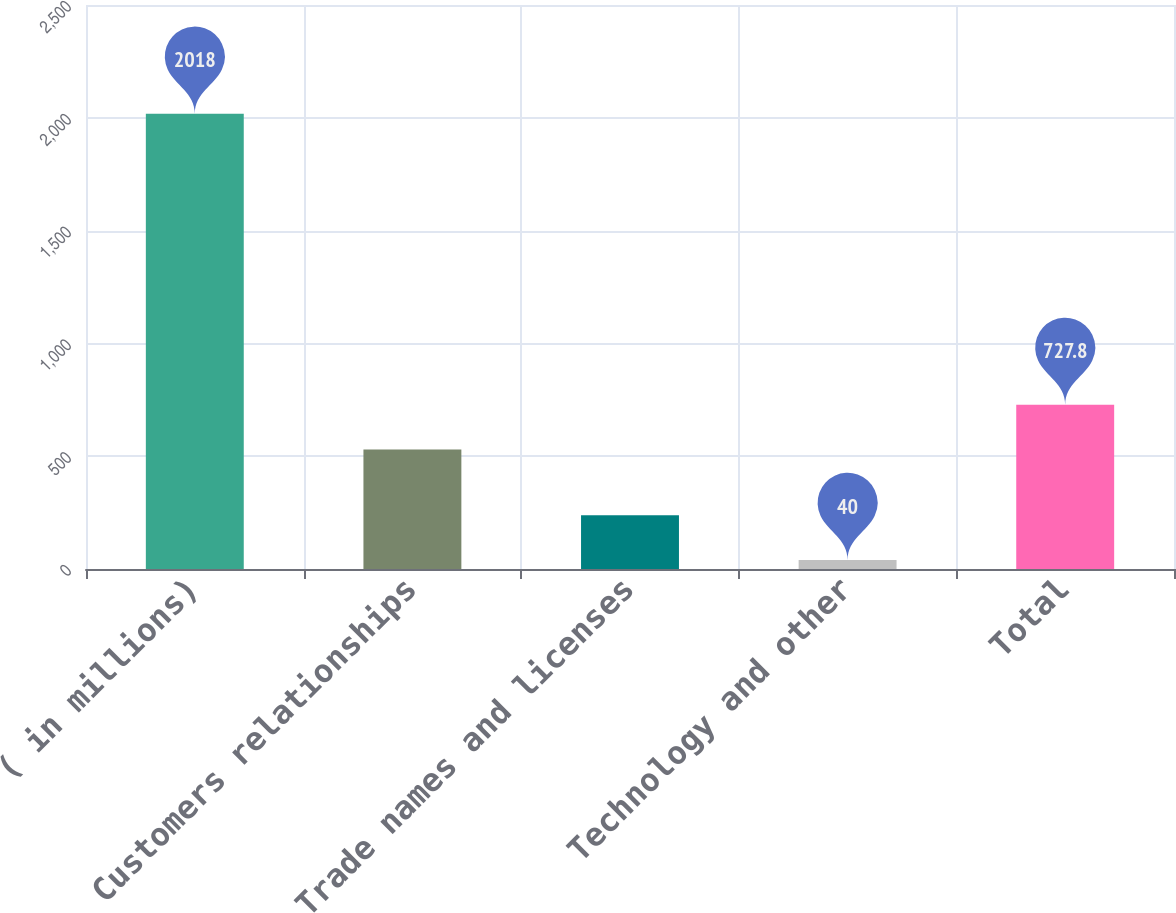<chart> <loc_0><loc_0><loc_500><loc_500><bar_chart><fcel>( in millions)<fcel>Customers relationships<fcel>Trade names and licenses<fcel>Technology and other<fcel>Total<nl><fcel>2018<fcel>530<fcel>237.8<fcel>40<fcel>727.8<nl></chart> 